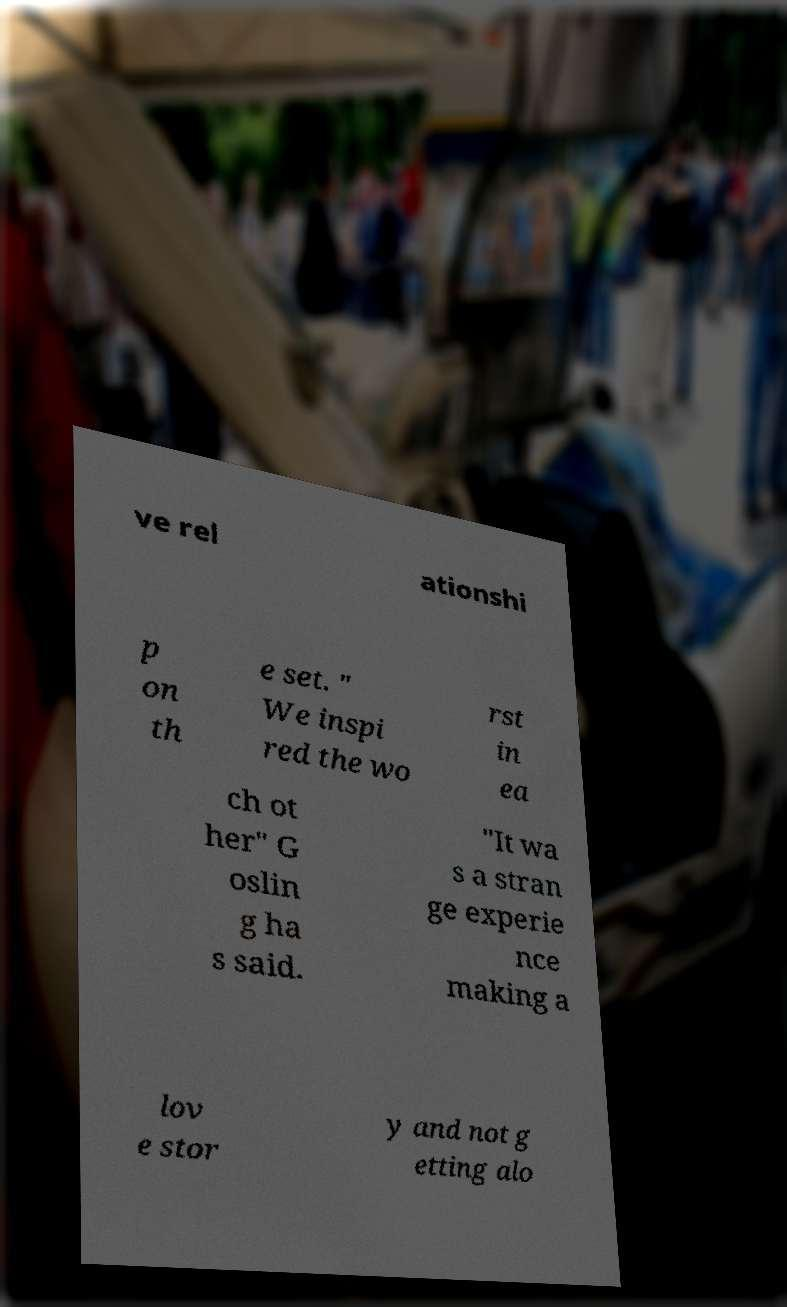Could you assist in decoding the text presented in this image and type it out clearly? ve rel ationshi p on th e set. " We inspi red the wo rst in ea ch ot her" G oslin g ha s said. "It wa s a stran ge experie nce making a lov e stor y and not g etting alo 